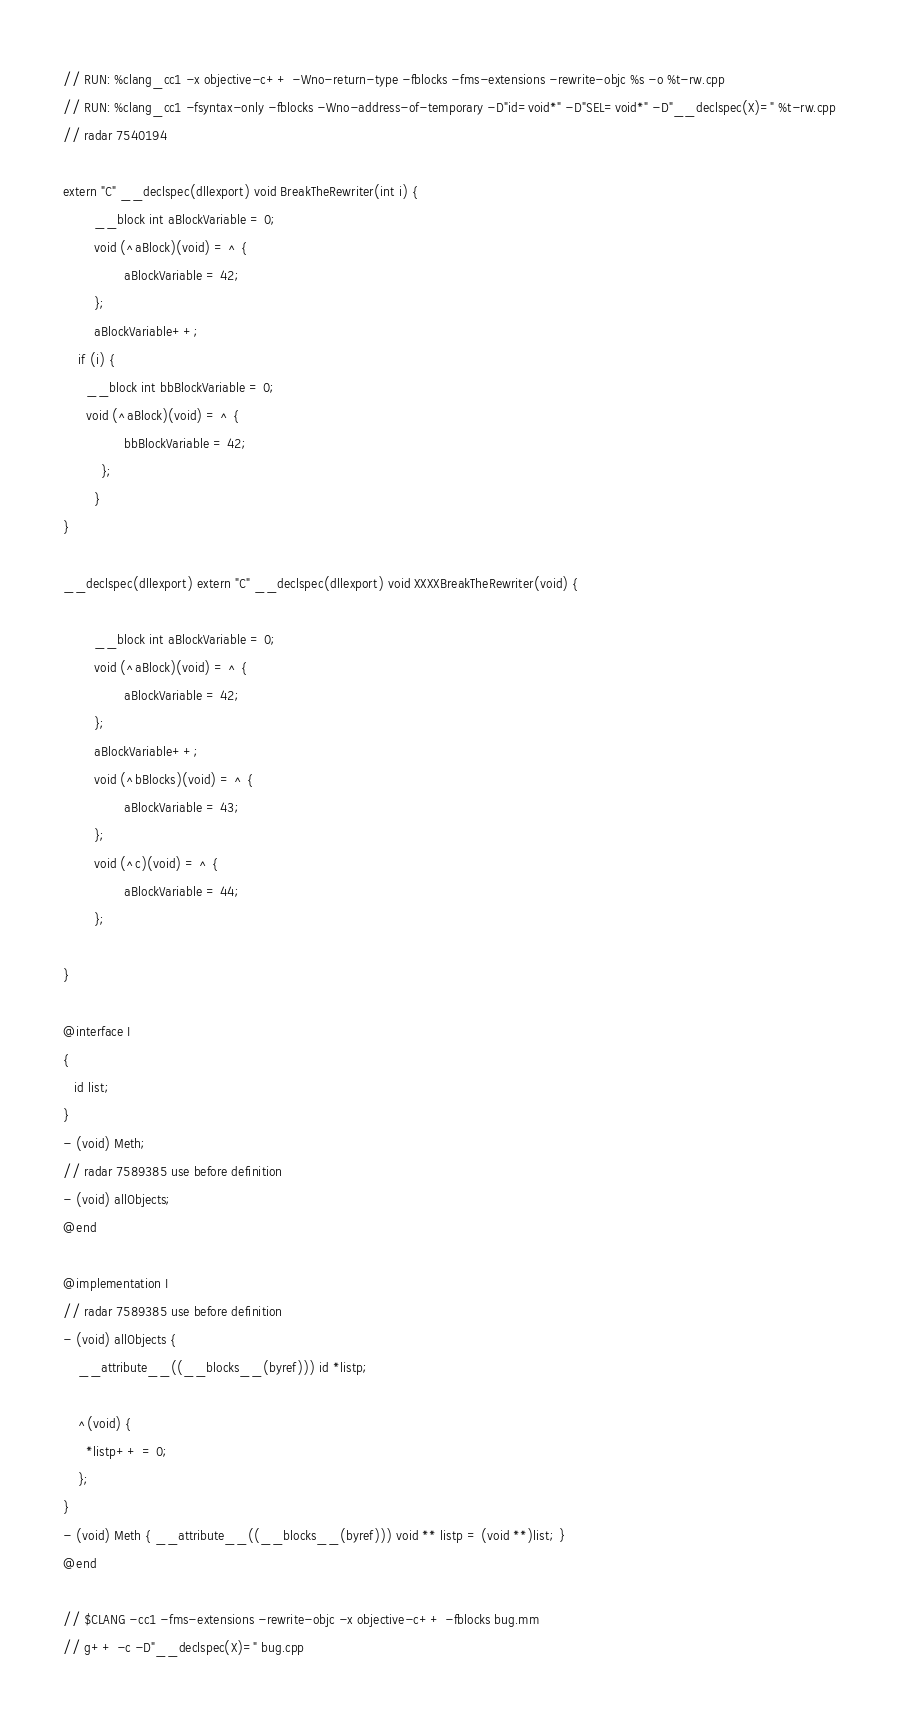<code> <loc_0><loc_0><loc_500><loc_500><_ObjectiveC_>// RUN: %clang_cc1 -x objective-c++ -Wno-return-type -fblocks -fms-extensions -rewrite-objc %s -o %t-rw.cpp
// RUN: %clang_cc1 -fsyntax-only -fblocks -Wno-address-of-temporary -D"id=void*" -D"SEL=void*" -D"__declspec(X)=" %t-rw.cpp
// radar 7540194

extern "C" __declspec(dllexport) void BreakTheRewriter(int i) {
        __block int aBlockVariable = 0;
        void (^aBlock)(void) = ^ {
                aBlockVariable = 42;
        };
        aBlockVariable++;
	if (i) {
	  __block int bbBlockVariable = 0;
	  void (^aBlock)(void) = ^ {
                bbBlockVariable = 42;
          };
        }
}

__declspec(dllexport) extern "C" __declspec(dllexport) void XXXXBreakTheRewriter(void) {

        __block int aBlockVariable = 0;
        void (^aBlock)(void) = ^ {
                aBlockVariable = 42;
        };
        aBlockVariable++;
        void (^bBlocks)(void) = ^ {
                aBlockVariable = 43;
        };
        void (^c)(void) = ^ {
                aBlockVariable = 44;
        };

}

@interface I
{
   id list;
}
- (void) Meth;
// radar 7589385 use before definition
- (void) allObjects;
@end

@implementation I
// radar 7589385 use before definition
- (void) allObjects {
    __attribute__((__blocks__(byref))) id *listp;

    ^(void) {
      *listp++ = 0;
    };
}
- (void) Meth { __attribute__((__blocks__(byref))) void ** listp = (void **)list; }
@end

// $CLANG -cc1 -fms-extensions -rewrite-objc -x objective-c++ -fblocks bug.mm
// g++ -c -D"__declspec(X)=" bug.cpp
</code> 